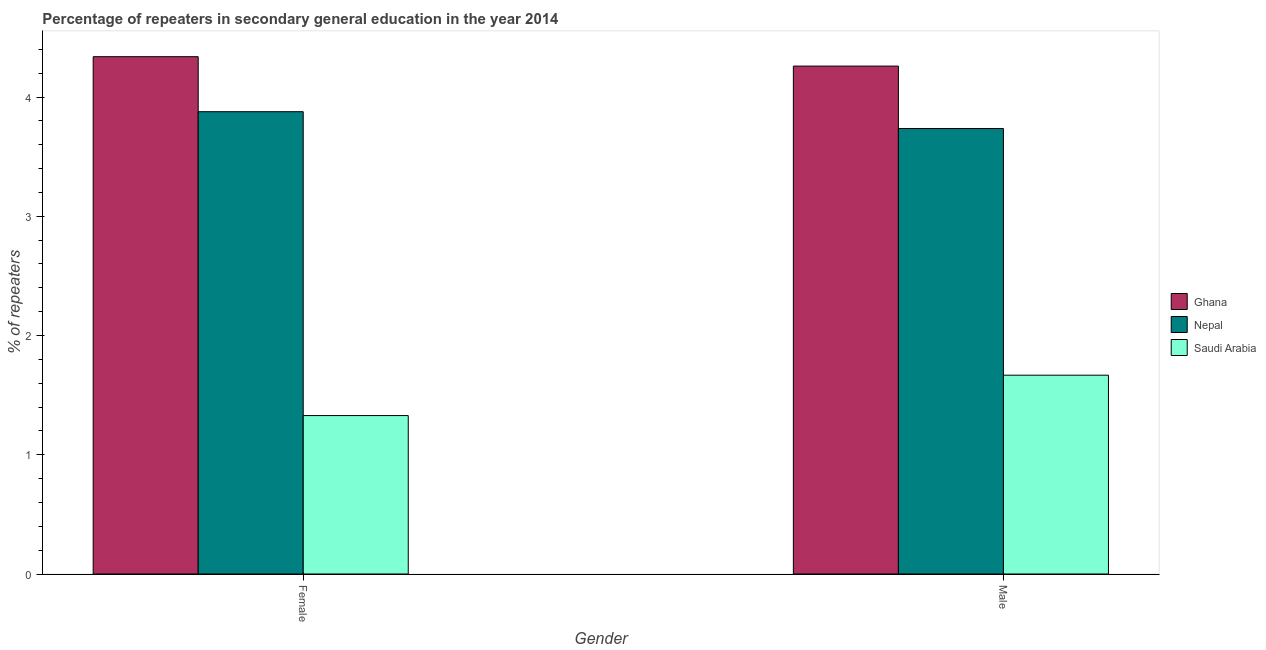How many different coloured bars are there?
Offer a very short reply. 3. How many groups of bars are there?
Your answer should be compact. 2. Are the number of bars on each tick of the X-axis equal?
Keep it short and to the point. Yes. How many bars are there on the 2nd tick from the left?
Offer a terse response. 3. How many bars are there on the 2nd tick from the right?
Keep it short and to the point. 3. What is the label of the 1st group of bars from the left?
Your answer should be very brief. Female. What is the percentage of female repeaters in Saudi Arabia?
Make the answer very short. 1.33. Across all countries, what is the maximum percentage of female repeaters?
Your answer should be compact. 4.34. Across all countries, what is the minimum percentage of male repeaters?
Your response must be concise. 1.67. In which country was the percentage of female repeaters minimum?
Provide a short and direct response. Saudi Arabia. What is the total percentage of female repeaters in the graph?
Make the answer very short. 9.54. What is the difference between the percentage of female repeaters in Ghana and that in Nepal?
Provide a short and direct response. 0.46. What is the difference between the percentage of female repeaters in Nepal and the percentage of male repeaters in Saudi Arabia?
Provide a short and direct response. 2.21. What is the average percentage of female repeaters per country?
Give a very brief answer. 3.18. What is the difference between the percentage of female repeaters and percentage of male repeaters in Saudi Arabia?
Your response must be concise. -0.34. In how many countries, is the percentage of female repeaters greater than 1.4 %?
Your answer should be compact. 2. What is the ratio of the percentage of male repeaters in Ghana to that in Nepal?
Your answer should be compact. 1.14. What does the 3rd bar from the left in Female represents?
Your answer should be compact. Saudi Arabia. Are all the bars in the graph horizontal?
Ensure brevity in your answer.  No. How many countries are there in the graph?
Give a very brief answer. 3. Does the graph contain grids?
Keep it short and to the point. No. Where does the legend appear in the graph?
Your response must be concise. Center right. How many legend labels are there?
Make the answer very short. 3. How are the legend labels stacked?
Offer a very short reply. Vertical. What is the title of the graph?
Ensure brevity in your answer.  Percentage of repeaters in secondary general education in the year 2014. What is the label or title of the X-axis?
Your answer should be very brief. Gender. What is the label or title of the Y-axis?
Offer a very short reply. % of repeaters. What is the % of repeaters in Ghana in Female?
Ensure brevity in your answer.  4.34. What is the % of repeaters in Nepal in Female?
Give a very brief answer. 3.88. What is the % of repeaters of Saudi Arabia in Female?
Your response must be concise. 1.33. What is the % of repeaters in Ghana in Male?
Offer a terse response. 4.26. What is the % of repeaters of Nepal in Male?
Your answer should be compact. 3.74. What is the % of repeaters of Saudi Arabia in Male?
Your answer should be very brief. 1.67. Across all Gender, what is the maximum % of repeaters of Ghana?
Provide a short and direct response. 4.34. Across all Gender, what is the maximum % of repeaters in Nepal?
Ensure brevity in your answer.  3.88. Across all Gender, what is the maximum % of repeaters in Saudi Arabia?
Offer a terse response. 1.67. Across all Gender, what is the minimum % of repeaters of Ghana?
Offer a very short reply. 4.26. Across all Gender, what is the minimum % of repeaters of Nepal?
Your response must be concise. 3.74. Across all Gender, what is the minimum % of repeaters in Saudi Arabia?
Offer a very short reply. 1.33. What is the total % of repeaters of Ghana in the graph?
Offer a terse response. 8.6. What is the total % of repeaters of Nepal in the graph?
Your answer should be very brief. 7.61. What is the total % of repeaters in Saudi Arabia in the graph?
Ensure brevity in your answer.  3. What is the difference between the % of repeaters in Ghana in Female and that in Male?
Keep it short and to the point. 0.08. What is the difference between the % of repeaters of Nepal in Female and that in Male?
Your response must be concise. 0.14. What is the difference between the % of repeaters in Saudi Arabia in Female and that in Male?
Your response must be concise. -0.34. What is the difference between the % of repeaters of Ghana in Female and the % of repeaters of Nepal in Male?
Offer a terse response. 0.6. What is the difference between the % of repeaters in Ghana in Female and the % of repeaters in Saudi Arabia in Male?
Ensure brevity in your answer.  2.67. What is the difference between the % of repeaters in Nepal in Female and the % of repeaters in Saudi Arabia in Male?
Give a very brief answer. 2.21. What is the average % of repeaters in Ghana per Gender?
Keep it short and to the point. 4.3. What is the average % of repeaters of Nepal per Gender?
Offer a terse response. 3.81. What is the average % of repeaters in Saudi Arabia per Gender?
Keep it short and to the point. 1.5. What is the difference between the % of repeaters in Ghana and % of repeaters in Nepal in Female?
Give a very brief answer. 0.46. What is the difference between the % of repeaters of Ghana and % of repeaters of Saudi Arabia in Female?
Provide a short and direct response. 3.01. What is the difference between the % of repeaters of Nepal and % of repeaters of Saudi Arabia in Female?
Provide a short and direct response. 2.55. What is the difference between the % of repeaters in Ghana and % of repeaters in Nepal in Male?
Ensure brevity in your answer.  0.52. What is the difference between the % of repeaters of Ghana and % of repeaters of Saudi Arabia in Male?
Your answer should be very brief. 2.59. What is the difference between the % of repeaters in Nepal and % of repeaters in Saudi Arabia in Male?
Ensure brevity in your answer.  2.07. What is the ratio of the % of repeaters in Ghana in Female to that in Male?
Your answer should be very brief. 1.02. What is the ratio of the % of repeaters in Nepal in Female to that in Male?
Keep it short and to the point. 1.04. What is the ratio of the % of repeaters in Saudi Arabia in Female to that in Male?
Provide a succinct answer. 0.8. What is the difference between the highest and the second highest % of repeaters in Ghana?
Your answer should be very brief. 0.08. What is the difference between the highest and the second highest % of repeaters of Nepal?
Your answer should be compact. 0.14. What is the difference between the highest and the second highest % of repeaters of Saudi Arabia?
Make the answer very short. 0.34. What is the difference between the highest and the lowest % of repeaters of Ghana?
Make the answer very short. 0.08. What is the difference between the highest and the lowest % of repeaters of Nepal?
Your response must be concise. 0.14. What is the difference between the highest and the lowest % of repeaters of Saudi Arabia?
Give a very brief answer. 0.34. 